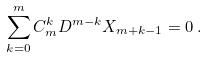<formula> <loc_0><loc_0><loc_500><loc_500>\sum _ { k = 0 } ^ { m } C ^ { k } _ { m } D ^ { m - k } X _ { m + k - 1 } = 0 \, .</formula> 